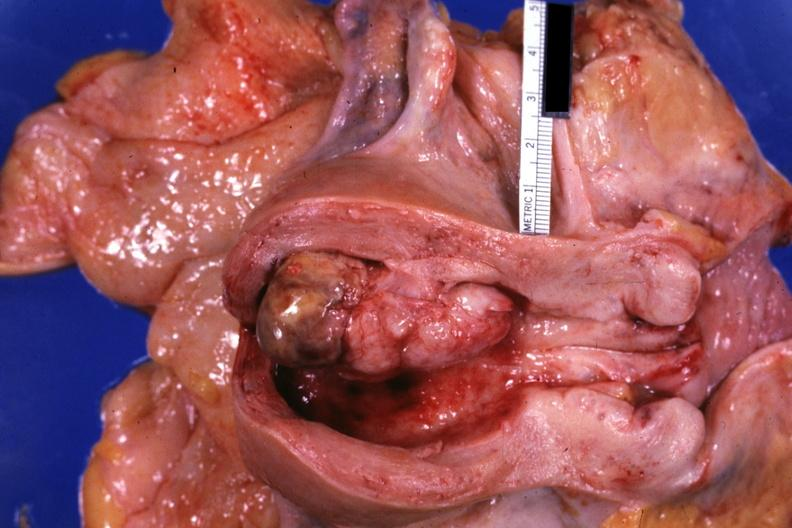s female reproductive present?
Answer the question using a single word or phrase. Yes 